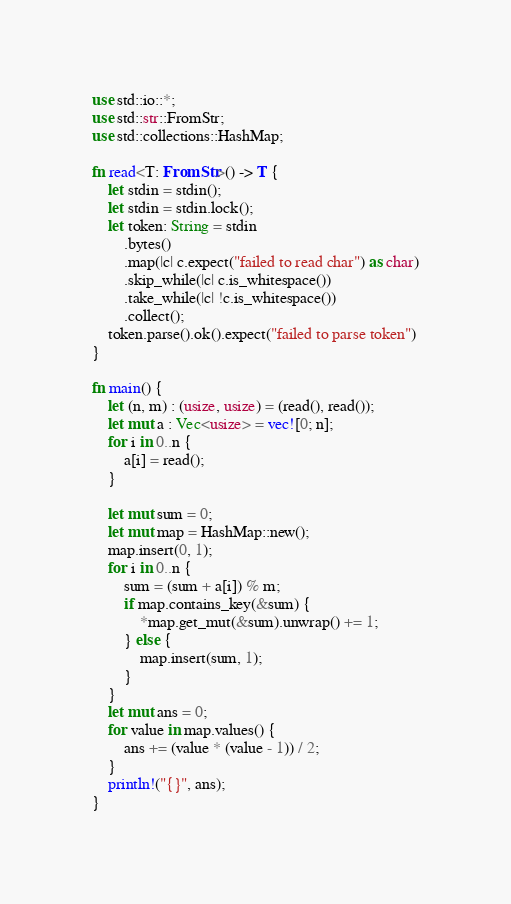<code> <loc_0><loc_0><loc_500><loc_500><_Rust_>use std::io::*;
use std::str::FromStr;
use std::collections::HashMap;

fn read<T: FromStr>() -> T {
    let stdin = stdin();
    let stdin = stdin.lock();
    let token: String = stdin
        .bytes()
        .map(|c| c.expect("failed to read char") as char)
        .skip_while(|c| c.is_whitespace())
        .take_while(|c| !c.is_whitespace())
        .collect();
    token.parse().ok().expect("failed to parse token")
}

fn main() {
    let (n, m) : (usize, usize) = (read(), read());
    let mut a : Vec<usize> = vec![0; n];
    for i in 0..n {
        a[i] = read();
    }

    let mut sum = 0;
    let mut map = HashMap::new();
    map.insert(0, 1);
    for i in 0..n {
        sum = (sum + a[i]) % m;
        if map.contains_key(&sum) {
            *map.get_mut(&sum).unwrap() += 1;
        } else {
            map.insert(sum, 1);
        }
    }
    let mut ans = 0;
    for value in map.values() {
        ans += (value * (value - 1)) / 2;
    }
    println!("{}", ans);
}
</code> 